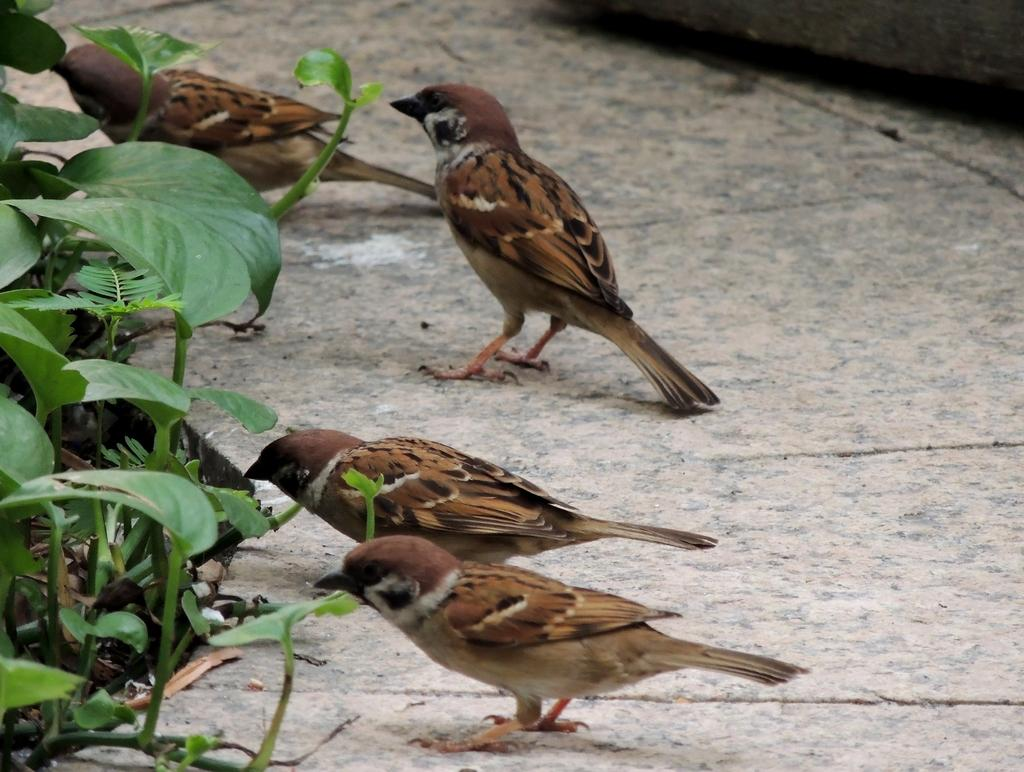What animals are on the floor in the image? There are birds on the floor in the image. What else is present in the image besides the birds? There are plants in front of the birds in the image. How many babies are being held by the horse in the image? There is no horse or babies present in the image; it features birds on the floor and plants in front of them. 